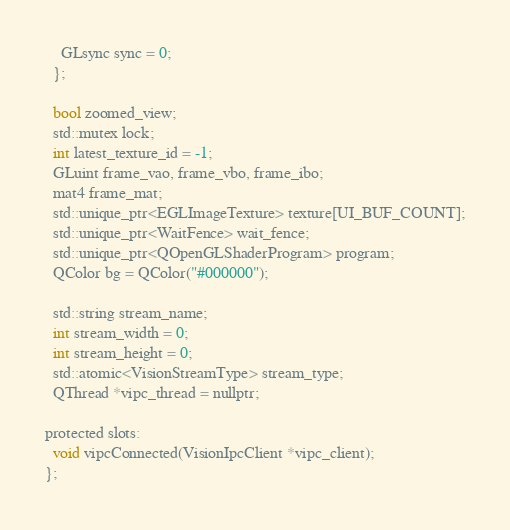<code> <loc_0><loc_0><loc_500><loc_500><_C_>    GLsync sync = 0;
  };

  bool zoomed_view;
  std::mutex lock;
  int latest_texture_id = -1;
  GLuint frame_vao, frame_vbo, frame_ibo;
  mat4 frame_mat;
  std::unique_ptr<EGLImageTexture> texture[UI_BUF_COUNT];
  std::unique_ptr<WaitFence> wait_fence;
  std::unique_ptr<QOpenGLShaderProgram> program;
  QColor bg = QColor("#000000");

  std::string stream_name;
  int stream_width = 0;
  int stream_height = 0;
  std::atomic<VisionStreamType> stream_type;
  QThread *vipc_thread = nullptr;

protected slots:
  void vipcConnected(VisionIpcClient *vipc_client);
};
</code> 